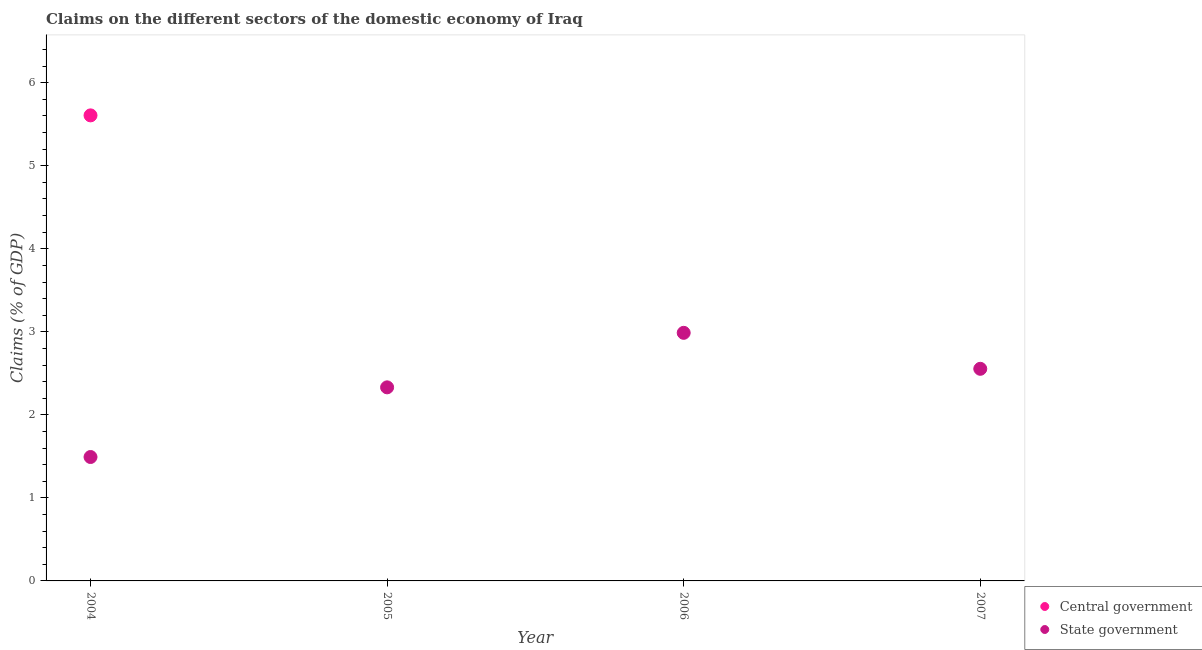How many different coloured dotlines are there?
Ensure brevity in your answer.  2. Is the number of dotlines equal to the number of legend labels?
Provide a succinct answer. No. What is the claims on state government in 2006?
Offer a very short reply. 2.99. Across all years, what is the maximum claims on state government?
Your response must be concise. 2.99. Across all years, what is the minimum claims on central government?
Your answer should be compact. 0. In which year was the claims on central government maximum?
Provide a short and direct response. 2004. What is the total claims on state government in the graph?
Your answer should be compact. 9.37. What is the difference between the claims on state government in 2004 and that in 2007?
Offer a very short reply. -1.06. What is the difference between the claims on state government in 2007 and the claims on central government in 2006?
Provide a short and direct response. 2.55. What is the average claims on central government per year?
Provide a short and direct response. 1.4. In the year 2004, what is the difference between the claims on central government and claims on state government?
Ensure brevity in your answer.  4.11. In how many years, is the claims on state government greater than 0.4 %?
Offer a very short reply. 4. What is the ratio of the claims on state government in 2004 to that in 2006?
Keep it short and to the point. 0.5. What is the difference between the highest and the second highest claims on state government?
Your answer should be very brief. 0.43. What is the difference between the highest and the lowest claims on central government?
Give a very brief answer. 5.61. Is the claims on central government strictly less than the claims on state government over the years?
Your response must be concise. No. How many years are there in the graph?
Give a very brief answer. 4. What is the difference between two consecutive major ticks on the Y-axis?
Offer a very short reply. 1. Are the values on the major ticks of Y-axis written in scientific E-notation?
Your answer should be compact. No. Where does the legend appear in the graph?
Give a very brief answer. Bottom right. How are the legend labels stacked?
Offer a very short reply. Vertical. What is the title of the graph?
Provide a short and direct response. Claims on the different sectors of the domestic economy of Iraq. What is the label or title of the X-axis?
Offer a terse response. Year. What is the label or title of the Y-axis?
Your answer should be very brief. Claims (% of GDP). What is the Claims (% of GDP) of Central government in 2004?
Your response must be concise. 5.61. What is the Claims (% of GDP) of State government in 2004?
Offer a very short reply. 1.49. What is the Claims (% of GDP) in Central government in 2005?
Keep it short and to the point. 0. What is the Claims (% of GDP) in State government in 2005?
Your response must be concise. 2.33. What is the Claims (% of GDP) in Central government in 2006?
Give a very brief answer. 0. What is the Claims (% of GDP) in State government in 2006?
Provide a succinct answer. 2.99. What is the Claims (% of GDP) of Central government in 2007?
Offer a very short reply. 0. What is the Claims (% of GDP) of State government in 2007?
Your response must be concise. 2.55. Across all years, what is the maximum Claims (% of GDP) of Central government?
Provide a succinct answer. 5.61. Across all years, what is the maximum Claims (% of GDP) of State government?
Provide a succinct answer. 2.99. Across all years, what is the minimum Claims (% of GDP) of State government?
Provide a short and direct response. 1.49. What is the total Claims (% of GDP) of Central government in the graph?
Ensure brevity in your answer.  5.61. What is the total Claims (% of GDP) in State government in the graph?
Keep it short and to the point. 9.37. What is the difference between the Claims (% of GDP) of State government in 2004 and that in 2005?
Ensure brevity in your answer.  -0.84. What is the difference between the Claims (% of GDP) in State government in 2004 and that in 2006?
Give a very brief answer. -1.5. What is the difference between the Claims (% of GDP) in State government in 2004 and that in 2007?
Provide a short and direct response. -1.06. What is the difference between the Claims (% of GDP) of State government in 2005 and that in 2006?
Provide a short and direct response. -0.66. What is the difference between the Claims (% of GDP) of State government in 2005 and that in 2007?
Keep it short and to the point. -0.22. What is the difference between the Claims (% of GDP) in State government in 2006 and that in 2007?
Offer a terse response. 0.43. What is the difference between the Claims (% of GDP) of Central government in 2004 and the Claims (% of GDP) of State government in 2005?
Give a very brief answer. 3.28. What is the difference between the Claims (% of GDP) in Central government in 2004 and the Claims (% of GDP) in State government in 2006?
Offer a terse response. 2.62. What is the difference between the Claims (% of GDP) in Central government in 2004 and the Claims (% of GDP) in State government in 2007?
Ensure brevity in your answer.  3.05. What is the average Claims (% of GDP) of Central government per year?
Keep it short and to the point. 1.4. What is the average Claims (% of GDP) of State government per year?
Your answer should be compact. 2.34. In the year 2004, what is the difference between the Claims (% of GDP) of Central government and Claims (% of GDP) of State government?
Ensure brevity in your answer.  4.11. What is the ratio of the Claims (% of GDP) in State government in 2004 to that in 2005?
Keep it short and to the point. 0.64. What is the ratio of the Claims (% of GDP) in State government in 2004 to that in 2006?
Your answer should be very brief. 0.5. What is the ratio of the Claims (% of GDP) of State government in 2004 to that in 2007?
Offer a terse response. 0.58. What is the ratio of the Claims (% of GDP) of State government in 2005 to that in 2006?
Keep it short and to the point. 0.78. What is the ratio of the Claims (% of GDP) of State government in 2005 to that in 2007?
Ensure brevity in your answer.  0.91. What is the ratio of the Claims (% of GDP) in State government in 2006 to that in 2007?
Your response must be concise. 1.17. What is the difference between the highest and the second highest Claims (% of GDP) in State government?
Provide a short and direct response. 0.43. What is the difference between the highest and the lowest Claims (% of GDP) in Central government?
Offer a very short reply. 5.61. What is the difference between the highest and the lowest Claims (% of GDP) of State government?
Your response must be concise. 1.5. 